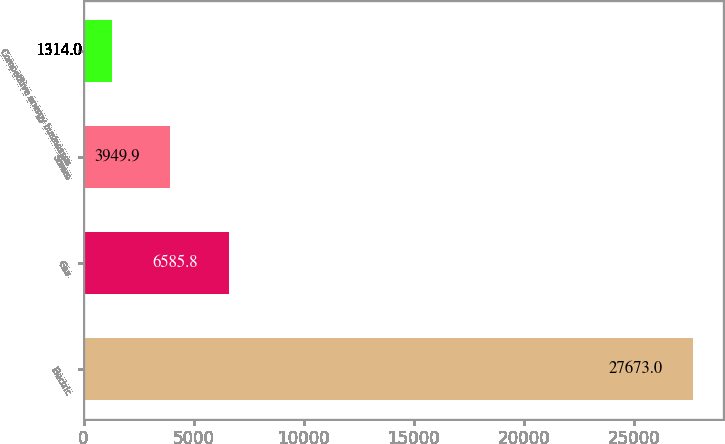Convert chart. <chart><loc_0><loc_0><loc_500><loc_500><bar_chart><fcel>Electric<fcel>Gas<fcel>Steam<fcel>Competitive energy businesses<nl><fcel>27673<fcel>6585.8<fcel>3949.9<fcel>1314<nl></chart> 